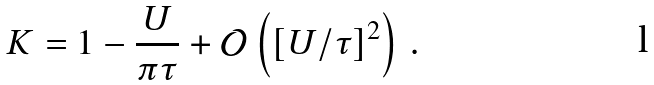Convert formula to latex. <formula><loc_0><loc_0><loc_500><loc_500>K = 1 - \frac { U } { \pi \tau } + { \mathcal { O } } \left ( [ U / \tau ] ^ { 2 } \right ) \, .</formula> 